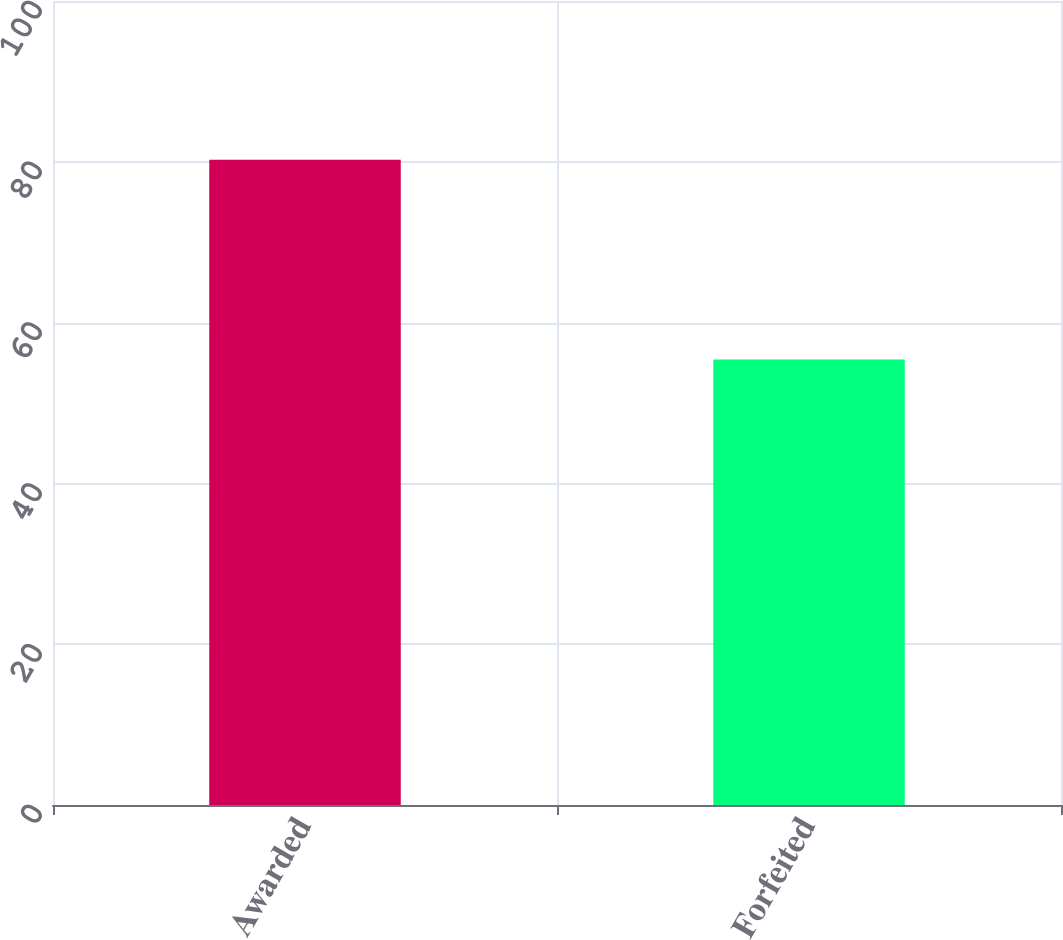Convert chart to OTSL. <chart><loc_0><loc_0><loc_500><loc_500><bar_chart><fcel>Awarded<fcel>Forfeited<nl><fcel>80.24<fcel>55.41<nl></chart> 